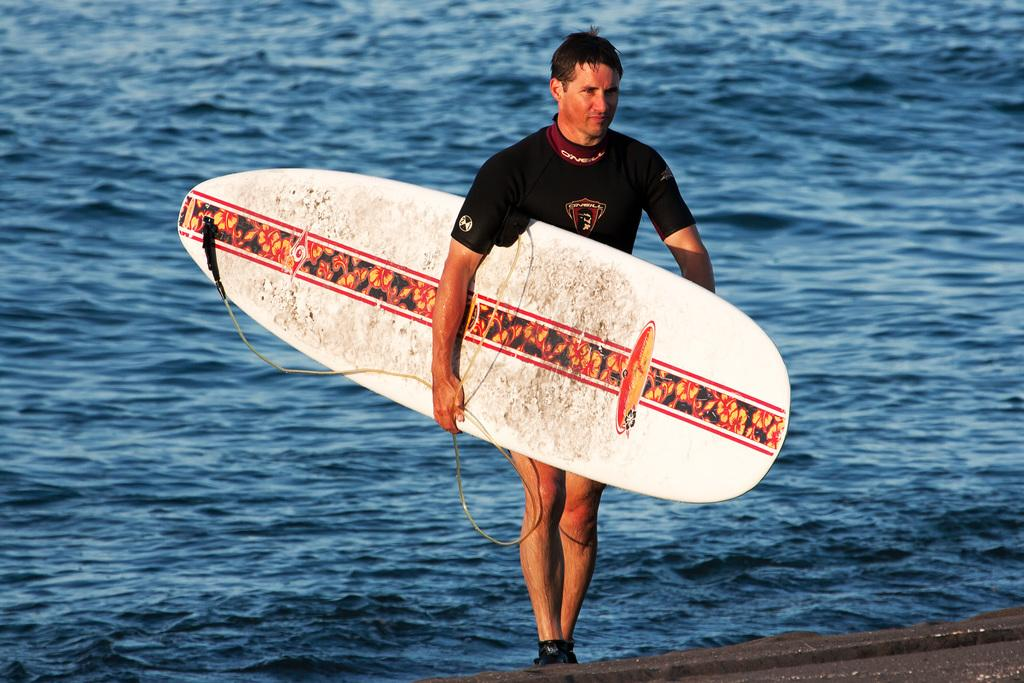Who is present in the image? There is a man in the image. What is the man holding in the image? The man is holding a white surfing board. What can be seen in the background of the image? There is water visible in the background of the image. What type of record can be seen on the surfing board in the image? There is no record present on the surfing board in the image. Can you spot any ants on the man's clothing in the image? There are no ants visible on the man's clothing in the image. 